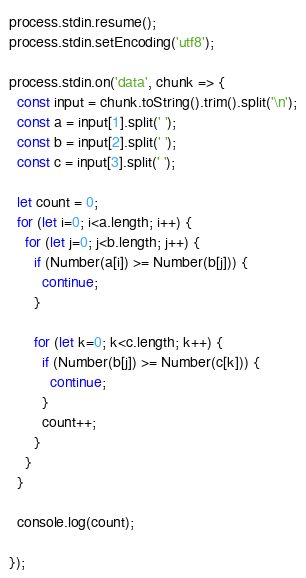<code> <loc_0><loc_0><loc_500><loc_500><_JavaScript_>process.stdin.resume();
process.stdin.setEncoding('utf8');

process.stdin.on('data', chunk => {
  const input = chunk.toString().trim().split('\n');
  const a = input[1].split(' ');
  const b = input[2].split(' ');
  const c = input[3].split(' ');

  let count = 0;
  for (let i=0; i<a.length; i++) {
    for (let j=0; j<b.length; j++) {
      if (Number(a[i]) >= Number(b[j])) {
        continue;
      }

      for (let k=0; k<c.length; k++) {
        if (Number(b[j]) >= Number(c[k])) {
          continue;
        }
        count++;
      }
    }
  }

  console.log(count);

});
</code> 